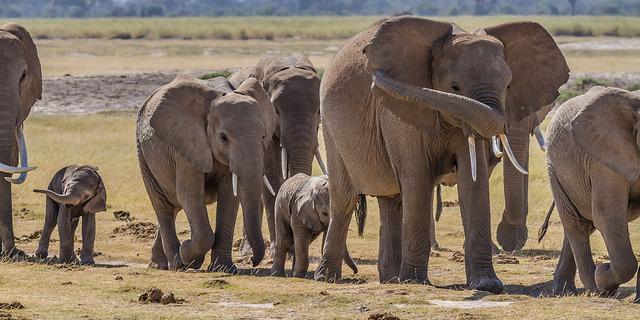Do the babies have tusks?
Be succinct. No. Have the animals been sheared?
Be succinct. No. How many total elephants are visible?
Write a very short answer. 7. How many elephants are not adults?
Be succinct. 2. 